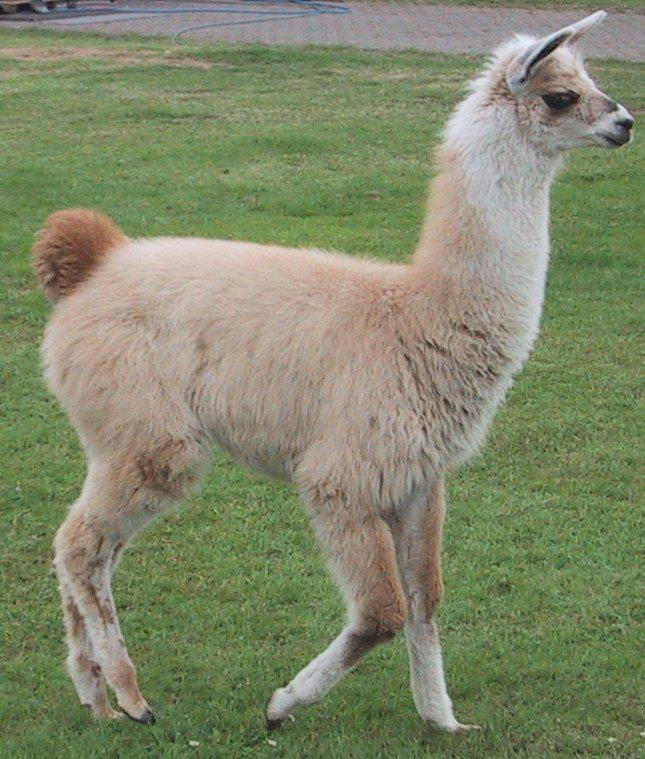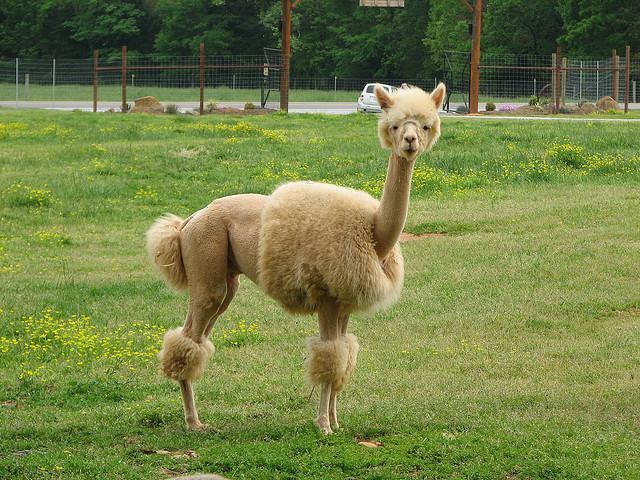The first image is the image on the left, the second image is the image on the right. For the images shown, is this caption "Each image contains a single llama, no llama looks straight at the camera, and the llamas on the left and right share similar fur coloring and body poses." true? Answer yes or no. No. The first image is the image on the left, the second image is the image on the right. Given the left and right images, does the statement "The left and right image contains the same number of Llamas facing the same direction." hold true? Answer yes or no. Yes. 